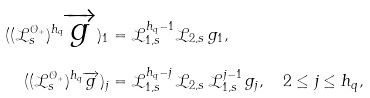Convert formula to latex. <formula><loc_0><loc_0><loc_500><loc_500>( ( \mathcal { L } _ { s } ^ { \mathcal { O } _ { + } } ) ^ { h _ { q } } \overrightarrow { g } ) _ { 1 } & = \mathcal { L } _ { 1 , s } ^ { h _ { q } - 1 } \mathcal { L } _ { 2 , s } \, g _ { 1 } , \\ ( ( \mathcal { L } _ { s } ^ { \mathcal { O } _ { + } } ) ^ { h _ { q } } \overrightarrow { g } ) _ { j } & = \mathcal { L } _ { 1 , s } ^ { h _ { q } - j } \, \mathcal { L } _ { 2 , s } \, \mathcal { L } _ { 1 , s } ^ { j - 1 } \, g _ { j } , \quad 2 \leq j \leq h _ { q } ,</formula> 